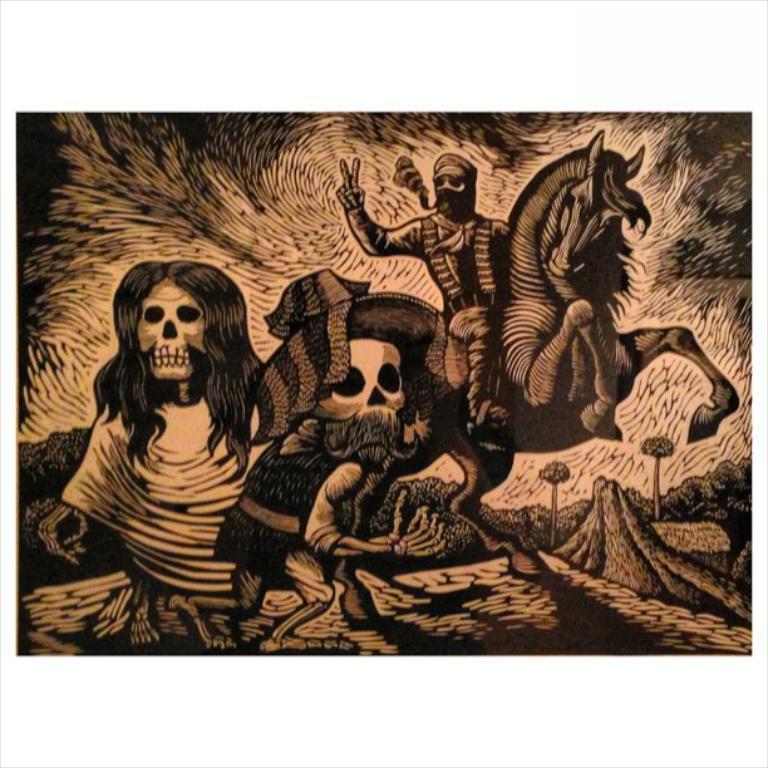Describe this image in one or two sentences. In this picture we can see drawing of monsters and a person on a horse. In the background we can see trees. 